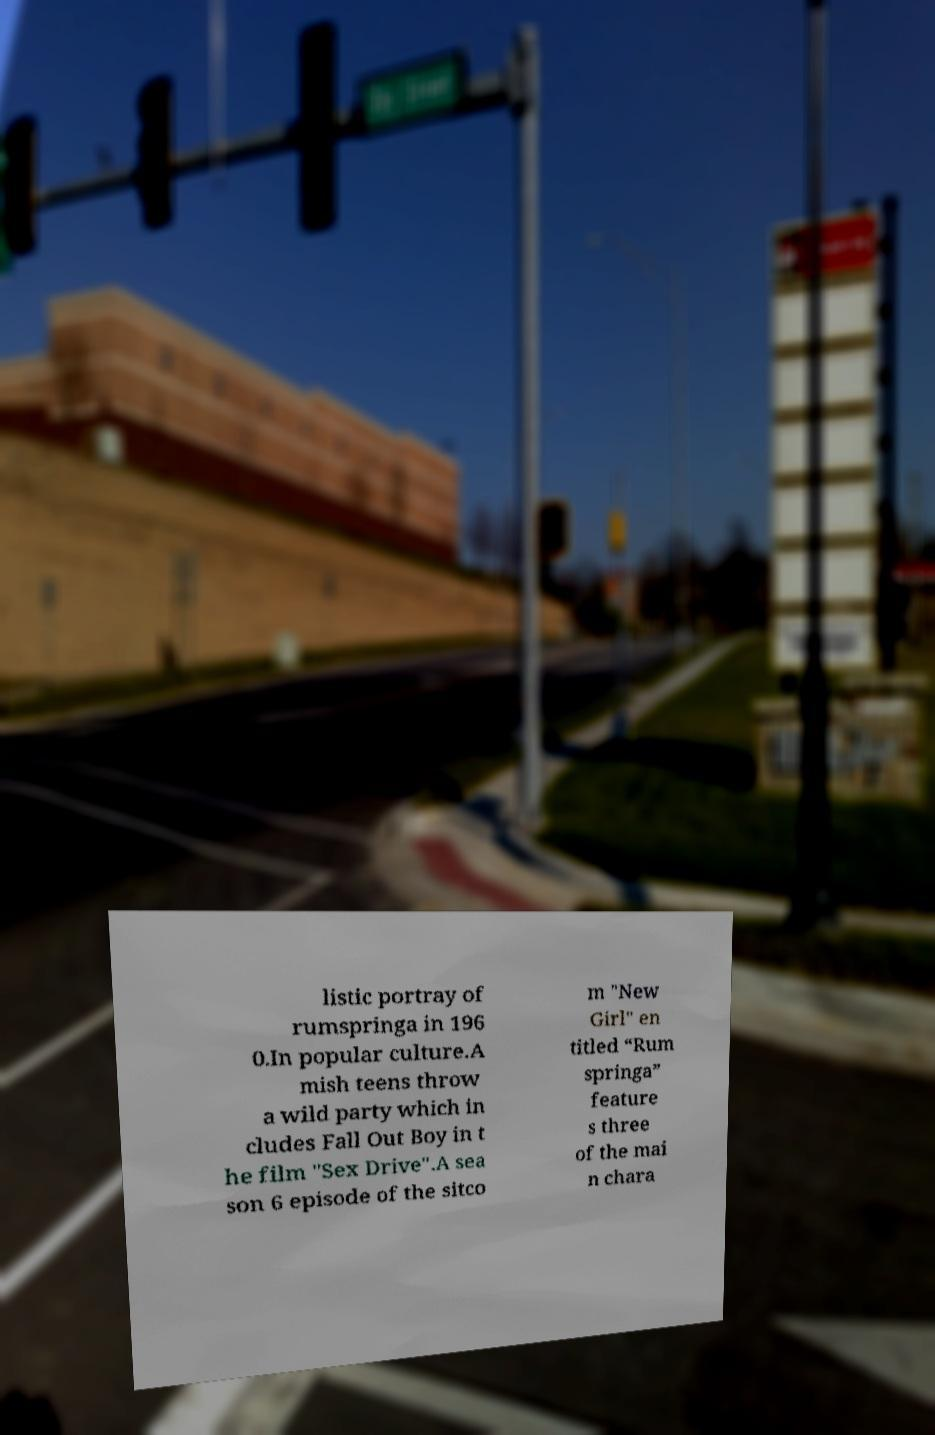Could you assist in decoding the text presented in this image and type it out clearly? listic portray of rumspringa in 196 0.In popular culture.A mish teens throw a wild party which in cludes Fall Out Boy in t he film "Sex Drive".A sea son 6 episode of the sitco m "New Girl" en titled “Rum springa” feature s three of the mai n chara 